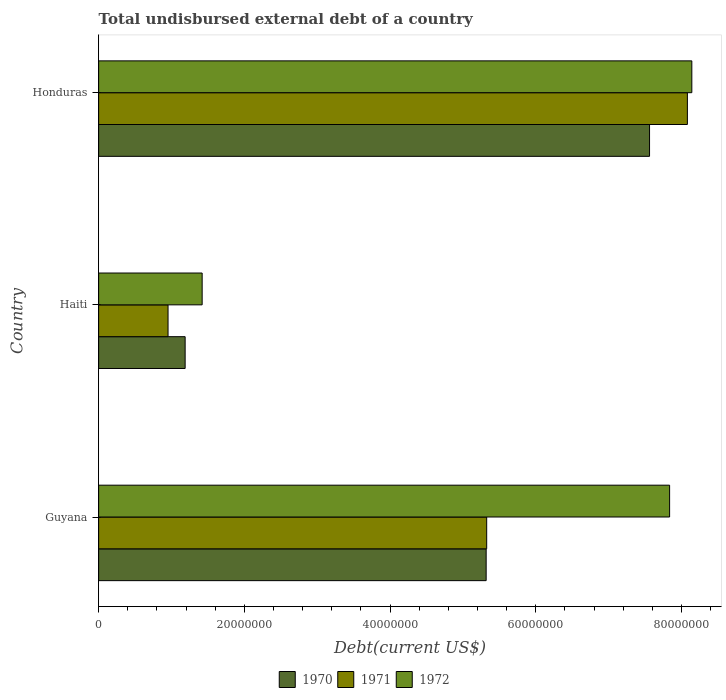How many groups of bars are there?
Your answer should be compact. 3. Are the number of bars on each tick of the Y-axis equal?
Provide a short and direct response. Yes. How many bars are there on the 3rd tick from the top?
Keep it short and to the point. 3. How many bars are there on the 3rd tick from the bottom?
Your response must be concise. 3. What is the label of the 2nd group of bars from the top?
Give a very brief answer. Haiti. In how many cases, is the number of bars for a given country not equal to the number of legend labels?
Ensure brevity in your answer.  0. What is the total undisbursed external debt in 1971 in Haiti?
Your response must be concise. 9.53e+06. Across all countries, what is the maximum total undisbursed external debt in 1972?
Offer a terse response. 8.14e+07. Across all countries, what is the minimum total undisbursed external debt in 1970?
Keep it short and to the point. 1.19e+07. In which country was the total undisbursed external debt in 1971 maximum?
Ensure brevity in your answer.  Honduras. In which country was the total undisbursed external debt in 1972 minimum?
Ensure brevity in your answer.  Haiti. What is the total total undisbursed external debt in 1972 in the graph?
Provide a succinct answer. 1.74e+08. What is the difference between the total undisbursed external debt in 1972 in Guyana and that in Honduras?
Offer a terse response. -3.05e+06. What is the difference between the total undisbursed external debt in 1970 in Honduras and the total undisbursed external debt in 1972 in Haiti?
Give a very brief answer. 6.14e+07. What is the average total undisbursed external debt in 1972 per country?
Your answer should be very brief. 5.80e+07. What is the difference between the total undisbursed external debt in 1971 and total undisbursed external debt in 1970 in Honduras?
Offer a very short reply. 5.20e+06. In how many countries, is the total undisbursed external debt in 1970 greater than 20000000 US$?
Give a very brief answer. 2. What is the ratio of the total undisbursed external debt in 1971 in Guyana to that in Haiti?
Ensure brevity in your answer.  5.59. Is the total undisbursed external debt in 1972 in Guyana less than that in Honduras?
Provide a succinct answer. Yes. What is the difference between the highest and the second highest total undisbursed external debt in 1970?
Your answer should be compact. 2.24e+07. What is the difference between the highest and the lowest total undisbursed external debt in 1970?
Ensure brevity in your answer.  6.37e+07. Is it the case that in every country, the sum of the total undisbursed external debt in 1970 and total undisbursed external debt in 1972 is greater than the total undisbursed external debt in 1971?
Ensure brevity in your answer.  Yes. Are the values on the major ticks of X-axis written in scientific E-notation?
Give a very brief answer. No. Where does the legend appear in the graph?
Your answer should be compact. Bottom center. What is the title of the graph?
Make the answer very short. Total undisbursed external debt of a country. What is the label or title of the X-axis?
Ensure brevity in your answer.  Debt(current US$). What is the label or title of the Y-axis?
Offer a very short reply. Country. What is the Debt(current US$) in 1970 in Guyana?
Your response must be concise. 5.32e+07. What is the Debt(current US$) in 1971 in Guyana?
Offer a terse response. 5.33e+07. What is the Debt(current US$) of 1972 in Guyana?
Offer a very short reply. 7.84e+07. What is the Debt(current US$) in 1970 in Haiti?
Provide a succinct answer. 1.19e+07. What is the Debt(current US$) in 1971 in Haiti?
Your answer should be compact. 9.53e+06. What is the Debt(current US$) of 1972 in Haiti?
Your answer should be very brief. 1.42e+07. What is the Debt(current US$) in 1970 in Honduras?
Provide a short and direct response. 7.56e+07. What is the Debt(current US$) in 1971 in Honduras?
Your answer should be very brief. 8.08e+07. What is the Debt(current US$) in 1972 in Honduras?
Provide a short and direct response. 8.14e+07. Across all countries, what is the maximum Debt(current US$) of 1970?
Your answer should be compact. 7.56e+07. Across all countries, what is the maximum Debt(current US$) of 1971?
Your response must be concise. 8.08e+07. Across all countries, what is the maximum Debt(current US$) in 1972?
Make the answer very short. 8.14e+07. Across all countries, what is the minimum Debt(current US$) of 1970?
Provide a succinct answer. 1.19e+07. Across all countries, what is the minimum Debt(current US$) of 1971?
Your response must be concise. 9.53e+06. Across all countries, what is the minimum Debt(current US$) in 1972?
Offer a terse response. 1.42e+07. What is the total Debt(current US$) of 1970 in the graph?
Provide a succinct answer. 1.41e+08. What is the total Debt(current US$) in 1971 in the graph?
Ensure brevity in your answer.  1.44e+08. What is the total Debt(current US$) of 1972 in the graph?
Provide a succinct answer. 1.74e+08. What is the difference between the Debt(current US$) in 1970 in Guyana and that in Haiti?
Make the answer very short. 4.13e+07. What is the difference between the Debt(current US$) in 1971 in Guyana and that in Haiti?
Ensure brevity in your answer.  4.37e+07. What is the difference between the Debt(current US$) of 1972 in Guyana and that in Haiti?
Offer a terse response. 6.42e+07. What is the difference between the Debt(current US$) in 1970 in Guyana and that in Honduras?
Provide a succinct answer. -2.24e+07. What is the difference between the Debt(current US$) of 1971 in Guyana and that in Honduras?
Make the answer very short. -2.75e+07. What is the difference between the Debt(current US$) of 1972 in Guyana and that in Honduras?
Provide a short and direct response. -3.05e+06. What is the difference between the Debt(current US$) in 1970 in Haiti and that in Honduras?
Your response must be concise. -6.37e+07. What is the difference between the Debt(current US$) of 1971 in Haiti and that in Honduras?
Provide a short and direct response. -7.13e+07. What is the difference between the Debt(current US$) of 1972 in Haiti and that in Honduras?
Offer a terse response. -6.72e+07. What is the difference between the Debt(current US$) in 1970 in Guyana and the Debt(current US$) in 1971 in Haiti?
Provide a succinct answer. 4.37e+07. What is the difference between the Debt(current US$) of 1970 in Guyana and the Debt(current US$) of 1972 in Haiti?
Your response must be concise. 3.90e+07. What is the difference between the Debt(current US$) in 1971 in Guyana and the Debt(current US$) in 1972 in Haiti?
Your response must be concise. 3.91e+07. What is the difference between the Debt(current US$) in 1970 in Guyana and the Debt(current US$) in 1971 in Honduras?
Offer a terse response. -2.76e+07. What is the difference between the Debt(current US$) of 1970 in Guyana and the Debt(current US$) of 1972 in Honduras?
Your answer should be compact. -2.82e+07. What is the difference between the Debt(current US$) in 1971 in Guyana and the Debt(current US$) in 1972 in Honduras?
Offer a terse response. -2.82e+07. What is the difference between the Debt(current US$) of 1970 in Haiti and the Debt(current US$) of 1971 in Honduras?
Ensure brevity in your answer.  -6.89e+07. What is the difference between the Debt(current US$) of 1970 in Haiti and the Debt(current US$) of 1972 in Honduras?
Your answer should be very brief. -6.96e+07. What is the difference between the Debt(current US$) in 1971 in Haiti and the Debt(current US$) in 1972 in Honduras?
Provide a short and direct response. -7.19e+07. What is the average Debt(current US$) of 1970 per country?
Give a very brief answer. 4.69e+07. What is the average Debt(current US$) in 1971 per country?
Ensure brevity in your answer.  4.79e+07. What is the average Debt(current US$) of 1972 per country?
Your response must be concise. 5.80e+07. What is the difference between the Debt(current US$) in 1970 and Debt(current US$) in 1971 in Guyana?
Your answer should be very brief. -7.30e+04. What is the difference between the Debt(current US$) of 1970 and Debt(current US$) of 1972 in Guyana?
Provide a short and direct response. -2.52e+07. What is the difference between the Debt(current US$) in 1971 and Debt(current US$) in 1972 in Guyana?
Provide a short and direct response. -2.51e+07. What is the difference between the Debt(current US$) of 1970 and Debt(current US$) of 1971 in Haiti?
Offer a very short reply. 2.35e+06. What is the difference between the Debt(current US$) of 1970 and Debt(current US$) of 1972 in Haiti?
Provide a short and direct response. -2.33e+06. What is the difference between the Debt(current US$) in 1971 and Debt(current US$) in 1972 in Haiti?
Ensure brevity in your answer.  -4.68e+06. What is the difference between the Debt(current US$) of 1970 and Debt(current US$) of 1971 in Honduras?
Keep it short and to the point. -5.20e+06. What is the difference between the Debt(current US$) in 1970 and Debt(current US$) in 1972 in Honduras?
Your response must be concise. -5.80e+06. What is the difference between the Debt(current US$) of 1971 and Debt(current US$) of 1972 in Honduras?
Keep it short and to the point. -6.09e+05. What is the ratio of the Debt(current US$) of 1970 in Guyana to that in Haiti?
Keep it short and to the point. 4.48. What is the ratio of the Debt(current US$) of 1971 in Guyana to that in Haiti?
Make the answer very short. 5.59. What is the ratio of the Debt(current US$) of 1972 in Guyana to that in Haiti?
Provide a short and direct response. 5.52. What is the ratio of the Debt(current US$) of 1970 in Guyana to that in Honduras?
Make the answer very short. 0.7. What is the ratio of the Debt(current US$) in 1971 in Guyana to that in Honduras?
Ensure brevity in your answer.  0.66. What is the ratio of the Debt(current US$) in 1972 in Guyana to that in Honduras?
Keep it short and to the point. 0.96. What is the ratio of the Debt(current US$) of 1970 in Haiti to that in Honduras?
Your answer should be very brief. 0.16. What is the ratio of the Debt(current US$) in 1971 in Haiti to that in Honduras?
Provide a succinct answer. 0.12. What is the ratio of the Debt(current US$) of 1972 in Haiti to that in Honduras?
Offer a very short reply. 0.17. What is the difference between the highest and the second highest Debt(current US$) of 1970?
Ensure brevity in your answer.  2.24e+07. What is the difference between the highest and the second highest Debt(current US$) of 1971?
Keep it short and to the point. 2.75e+07. What is the difference between the highest and the second highest Debt(current US$) of 1972?
Provide a short and direct response. 3.05e+06. What is the difference between the highest and the lowest Debt(current US$) of 1970?
Offer a very short reply. 6.37e+07. What is the difference between the highest and the lowest Debt(current US$) of 1971?
Offer a very short reply. 7.13e+07. What is the difference between the highest and the lowest Debt(current US$) in 1972?
Make the answer very short. 6.72e+07. 